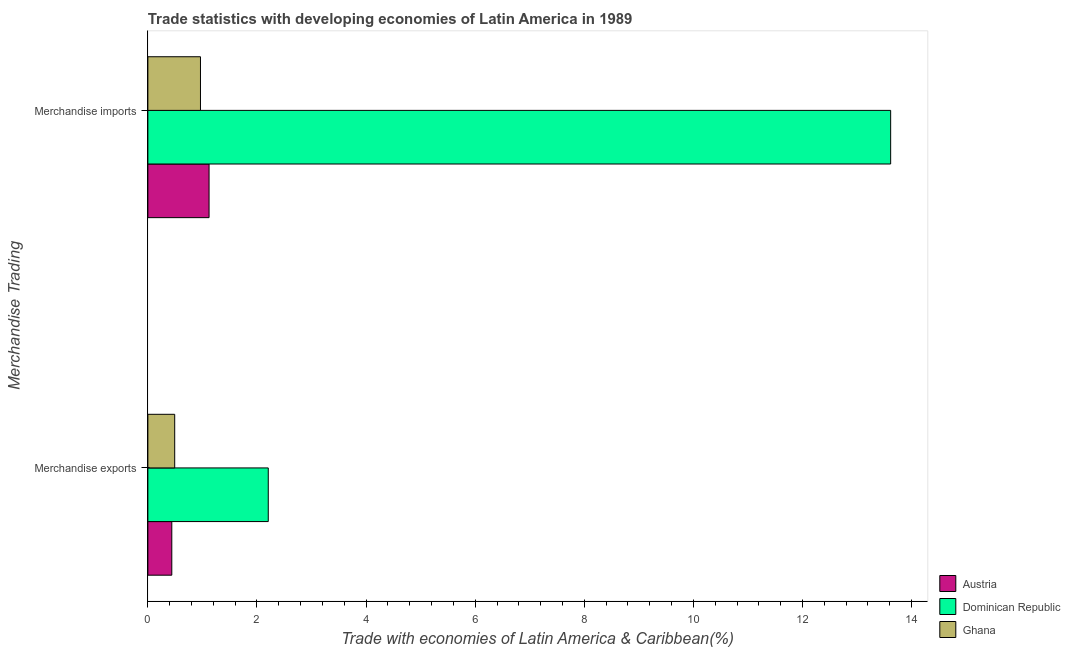How many different coloured bars are there?
Your response must be concise. 3. Are the number of bars per tick equal to the number of legend labels?
Your answer should be compact. Yes. What is the label of the 2nd group of bars from the top?
Offer a very short reply. Merchandise exports. What is the merchandise exports in Dominican Republic?
Provide a succinct answer. 2.21. Across all countries, what is the maximum merchandise imports?
Your response must be concise. 13.62. Across all countries, what is the minimum merchandise exports?
Your response must be concise. 0.44. In which country was the merchandise exports maximum?
Provide a short and direct response. Dominican Republic. What is the total merchandise imports in the graph?
Make the answer very short. 15.7. What is the difference between the merchandise exports in Austria and that in Dominican Republic?
Give a very brief answer. -1.77. What is the difference between the merchandise imports in Austria and the merchandise exports in Ghana?
Your answer should be very brief. 0.63. What is the average merchandise exports per country?
Provide a short and direct response. 1.05. What is the difference between the merchandise exports and merchandise imports in Austria?
Ensure brevity in your answer.  -0.68. What is the ratio of the merchandise imports in Ghana to that in Austria?
Ensure brevity in your answer.  0.86. Is the merchandise exports in Austria less than that in Ghana?
Your answer should be very brief. Yes. In how many countries, is the merchandise imports greater than the average merchandise imports taken over all countries?
Provide a succinct answer. 1. What does the 1st bar from the top in Merchandise exports represents?
Your response must be concise. Ghana. What does the 2nd bar from the bottom in Merchandise imports represents?
Keep it short and to the point. Dominican Republic. Does the graph contain any zero values?
Offer a very short reply. No. Where does the legend appear in the graph?
Your response must be concise. Bottom right. How are the legend labels stacked?
Provide a succinct answer. Vertical. What is the title of the graph?
Give a very brief answer. Trade statistics with developing economies of Latin America in 1989. What is the label or title of the X-axis?
Give a very brief answer. Trade with economies of Latin America & Caribbean(%). What is the label or title of the Y-axis?
Offer a terse response. Merchandise Trading. What is the Trade with economies of Latin America & Caribbean(%) of Austria in Merchandise exports?
Provide a short and direct response. 0.44. What is the Trade with economies of Latin America & Caribbean(%) of Dominican Republic in Merchandise exports?
Keep it short and to the point. 2.21. What is the Trade with economies of Latin America & Caribbean(%) in Ghana in Merchandise exports?
Provide a succinct answer. 0.49. What is the Trade with economies of Latin America & Caribbean(%) of Austria in Merchandise imports?
Provide a short and direct response. 1.12. What is the Trade with economies of Latin America & Caribbean(%) in Dominican Republic in Merchandise imports?
Keep it short and to the point. 13.62. What is the Trade with economies of Latin America & Caribbean(%) in Ghana in Merchandise imports?
Your response must be concise. 0.96. Across all Merchandise Trading, what is the maximum Trade with economies of Latin America & Caribbean(%) in Austria?
Provide a short and direct response. 1.12. Across all Merchandise Trading, what is the maximum Trade with economies of Latin America & Caribbean(%) in Dominican Republic?
Your answer should be compact. 13.62. Across all Merchandise Trading, what is the maximum Trade with economies of Latin America & Caribbean(%) of Ghana?
Ensure brevity in your answer.  0.96. Across all Merchandise Trading, what is the minimum Trade with economies of Latin America & Caribbean(%) in Austria?
Provide a short and direct response. 0.44. Across all Merchandise Trading, what is the minimum Trade with economies of Latin America & Caribbean(%) of Dominican Republic?
Ensure brevity in your answer.  2.21. Across all Merchandise Trading, what is the minimum Trade with economies of Latin America & Caribbean(%) in Ghana?
Your answer should be very brief. 0.49. What is the total Trade with economies of Latin America & Caribbean(%) in Austria in the graph?
Offer a terse response. 1.56. What is the total Trade with economies of Latin America & Caribbean(%) in Dominican Republic in the graph?
Make the answer very short. 15.82. What is the total Trade with economies of Latin America & Caribbean(%) in Ghana in the graph?
Offer a very short reply. 1.46. What is the difference between the Trade with economies of Latin America & Caribbean(%) of Austria in Merchandise exports and that in Merchandise imports?
Give a very brief answer. -0.68. What is the difference between the Trade with economies of Latin America & Caribbean(%) in Dominican Republic in Merchandise exports and that in Merchandise imports?
Keep it short and to the point. -11.41. What is the difference between the Trade with economies of Latin America & Caribbean(%) of Ghana in Merchandise exports and that in Merchandise imports?
Provide a short and direct response. -0.47. What is the difference between the Trade with economies of Latin America & Caribbean(%) of Austria in Merchandise exports and the Trade with economies of Latin America & Caribbean(%) of Dominican Republic in Merchandise imports?
Your response must be concise. -13.18. What is the difference between the Trade with economies of Latin America & Caribbean(%) in Austria in Merchandise exports and the Trade with economies of Latin America & Caribbean(%) in Ghana in Merchandise imports?
Keep it short and to the point. -0.53. What is the difference between the Trade with economies of Latin America & Caribbean(%) of Dominican Republic in Merchandise exports and the Trade with economies of Latin America & Caribbean(%) of Ghana in Merchandise imports?
Your response must be concise. 1.24. What is the average Trade with economies of Latin America & Caribbean(%) in Austria per Merchandise Trading?
Your answer should be very brief. 0.78. What is the average Trade with economies of Latin America & Caribbean(%) of Dominican Republic per Merchandise Trading?
Make the answer very short. 7.91. What is the average Trade with economies of Latin America & Caribbean(%) of Ghana per Merchandise Trading?
Offer a very short reply. 0.73. What is the difference between the Trade with economies of Latin America & Caribbean(%) in Austria and Trade with economies of Latin America & Caribbean(%) in Dominican Republic in Merchandise exports?
Provide a short and direct response. -1.77. What is the difference between the Trade with economies of Latin America & Caribbean(%) of Austria and Trade with economies of Latin America & Caribbean(%) of Ghana in Merchandise exports?
Offer a terse response. -0.05. What is the difference between the Trade with economies of Latin America & Caribbean(%) in Dominican Republic and Trade with economies of Latin America & Caribbean(%) in Ghana in Merchandise exports?
Your answer should be compact. 1.72. What is the difference between the Trade with economies of Latin America & Caribbean(%) of Austria and Trade with economies of Latin America & Caribbean(%) of Dominican Republic in Merchandise imports?
Offer a terse response. -12.49. What is the difference between the Trade with economies of Latin America & Caribbean(%) in Austria and Trade with economies of Latin America & Caribbean(%) in Ghana in Merchandise imports?
Your answer should be very brief. 0.16. What is the difference between the Trade with economies of Latin America & Caribbean(%) of Dominican Republic and Trade with economies of Latin America & Caribbean(%) of Ghana in Merchandise imports?
Ensure brevity in your answer.  12.65. What is the ratio of the Trade with economies of Latin America & Caribbean(%) of Austria in Merchandise exports to that in Merchandise imports?
Offer a very short reply. 0.39. What is the ratio of the Trade with economies of Latin America & Caribbean(%) of Dominican Republic in Merchandise exports to that in Merchandise imports?
Make the answer very short. 0.16. What is the ratio of the Trade with economies of Latin America & Caribbean(%) of Ghana in Merchandise exports to that in Merchandise imports?
Your answer should be compact. 0.51. What is the difference between the highest and the second highest Trade with economies of Latin America & Caribbean(%) in Austria?
Offer a terse response. 0.68. What is the difference between the highest and the second highest Trade with economies of Latin America & Caribbean(%) of Dominican Republic?
Offer a very short reply. 11.41. What is the difference between the highest and the second highest Trade with economies of Latin America & Caribbean(%) of Ghana?
Your response must be concise. 0.47. What is the difference between the highest and the lowest Trade with economies of Latin America & Caribbean(%) of Austria?
Give a very brief answer. 0.68. What is the difference between the highest and the lowest Trade with economies of Latin America & Caribbean(%) in Dominican Republic?
Provide a succinct answer. 11.41. What is the difference between the highest and the lowest Trade with economies of Latin America & Caribbean(%) of Ghana?
Your response must be concise. 0.47. 